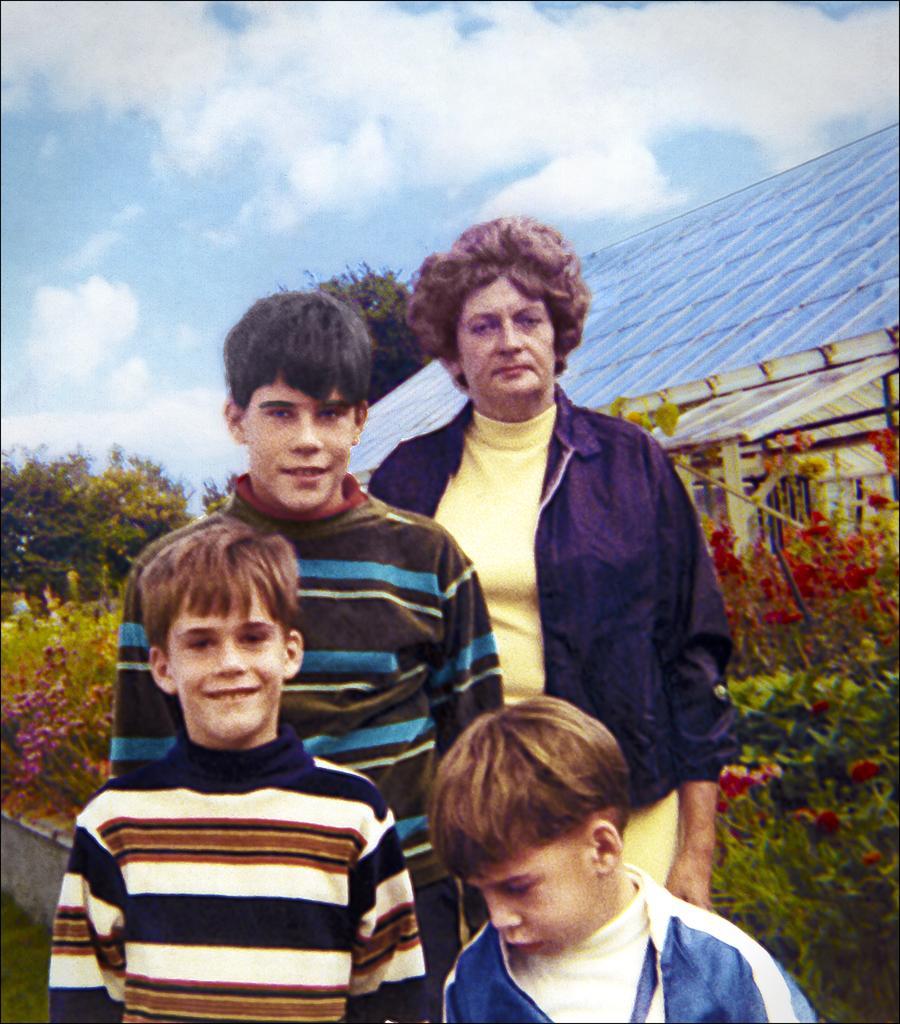Describe this image in one or two sentences. In this image there is a painting, in the painting there are three boys and a woman posing for the camera with a smile on their face, behind them there are trees and a house. 